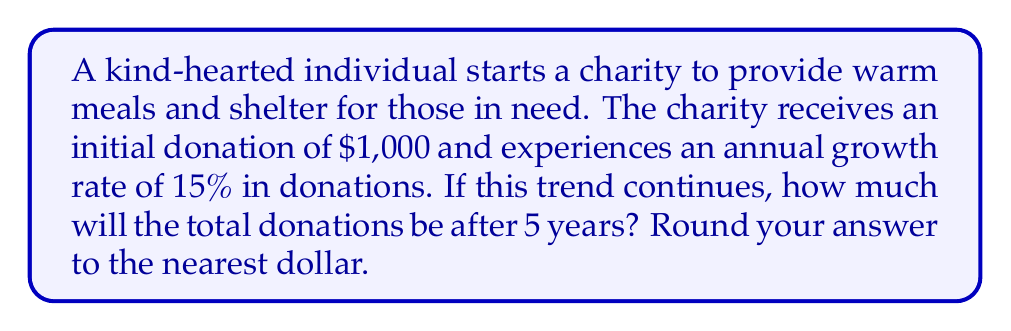Show me your answer to this math problem. Let's approach this step-by-step using the exponential growth formula:

1) The exponential growth formula is:
   $A = P(1 + r)^t$
   Where:
   $A$ = Final amount
   $P$ = Initial principal balance
   $r$ = Annual growth rate (in decimal form)
   $t$ = Number of years

2) We know:
   $P = 1000$ (initial donation)
   $r = 0.15$ (15% annual growth rate)
   $t = 5$ years

3) Let's plug these values into our formula:
   $A = 1000(1 + 0.15)^5$

4) Simplify inside the parentheses:
   $A = 1000(1.15)^5$

5) Calculate the exponent:
   $(1.15)^5 = 2.0113689$

6) Multiply:
   $A = 1000 * 2.0113689 = 2011.3689$

7) Round to the nearest dollar:
   $A ≈ 2011$

Therefore, after 5 years, the total donations will be approximately $2,011.
Answer: $2,011 